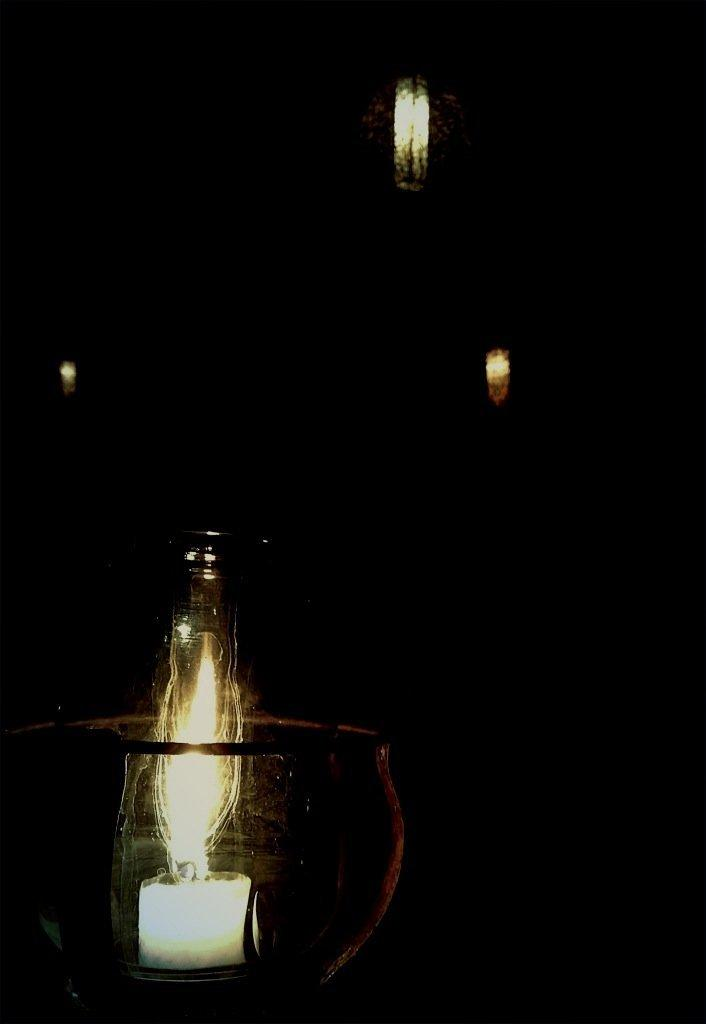What can be seen in the image that provides illumination? There are lights in the image. What is the color or tone of the background in the image? The background of the image is dark. Can you see a friend holding a steel container filled with liquid in the image? There is no friend, steel container, or liquid present in the image. 